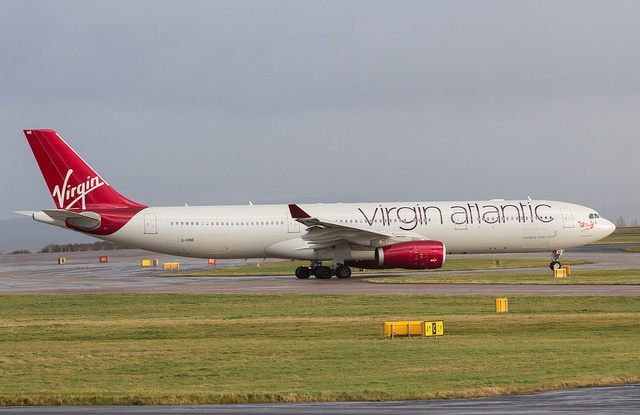Describe the objects in this image and their specific colors. I can see a airplane in darkgray, lightgray, gray, and brown tones in this image. 